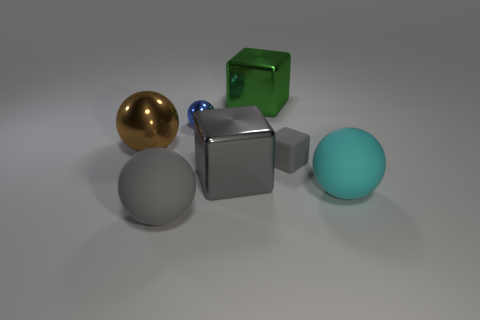Subtract 1 balls. How many balls are left? 3 Subtract all green balls. Subtract all brown cubes. How many balls are left? 4 Add 2 red metallic cubes. How many objects exist? 9 Subtract all cubes. How many objects are left? 4 Add 4 gray rubber cubes. How many gray rubber cubes are left? 5 Add 6 tiny shiny objects. How many tiny shiny objects exist? 7 Subtract 0 red cubes. How many objects are left? 7 Subtract all large yellow rubber blocks. Subtract all matte things. How many objects are left? 4 